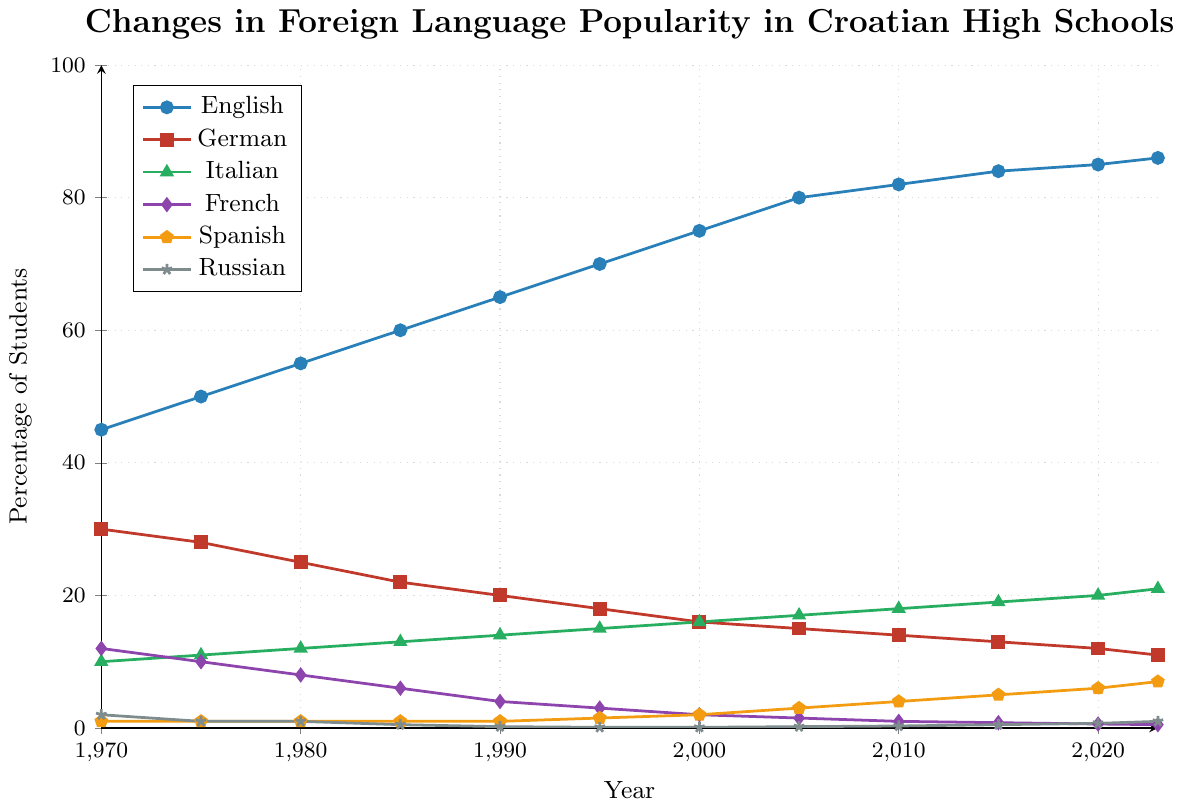Which foreign language had the highest percentage of students in the latest year? According to the chart, in the year 2023, the line representing English is at the highest point among all languages. This indicates that English had the highest percentage of students.
Answer: English Between which two years did the percentage of students learning Spanish increase the most? By examining the upward trend of the Spanish line, the biggest increase occurs between 2000 and 2005, where the line representing Spanish jumps from 2% to 3%.
Answer: 2000 and 2005 What is the difference in the percentage of students studying French between 1970 and 2023? The percentage of students studying French decreases from 12% in 1970 to 0.5% in 2023. The difference can be calculated as 12% - 0.5% = 11.5%.
Answer: 11.5% Which language saw the smallest change in percentage of students from 1970 to 2023? Observing the lines for each language, Russian shows the smallest change, with its percentage changing from 2% in 1970 to 1% in 2023. Other languages exhibit much greater changes in their percentages.
Answer: Russian In which decade did German see the most significant decrease in its student percentage? By looking at the German line, the most noticeable drop occurs between the 1980s and 1990s, decreasing from 25% in 1980 to 20% in 1990, a difference of 5%.
Answer: 1980s to 1990s Calculate the average percentage of students studying Italian from 1970 to 2023. To find the average, sum the percentages of Italian over all the years provided and divide by the number of data points. Calculating: (10 + 11 + 12 + 13 + 14 + 15 + 16 + 17 + 18 + 19 + 20 + 21) / 12 = 16.
Answer: 16 Which language has shown a consistent increase in popularity every year since 1970? By visually assessing the trends of the lines for each language, Italian has shown a consistent increase, starting at 10% in 1970 and rising steadily to 21% in 2023.
Answer: Italian What is the combined percentage of students studying Spanish and Russian in 2023? The chart indicates that in 2023, the percentage of students studying Spanish is 7%, and for Russian, it is 1%. Adding these together: 7% + 1% = 8%.
Answer: 8% Between 2010 and 2015, did the percentage of students studying French decline more sharply than in any other 5-year interval? By examining the French line, the decrease from 2010 to 2015 is from 1% to 0.8%, a reduction of 0.2%. Other five-year intervals show larger decreases, such as from 1990 to 1995 (4% to 3%, a 1% decrease).
Answer: No Which year shows the intersection of the German and Italian lines, and what does this indicate? The German and Italian lines intersect around the year 2008. This indicates that in this year, the percentage of students studying both languages was equal.
Answer: 2008 